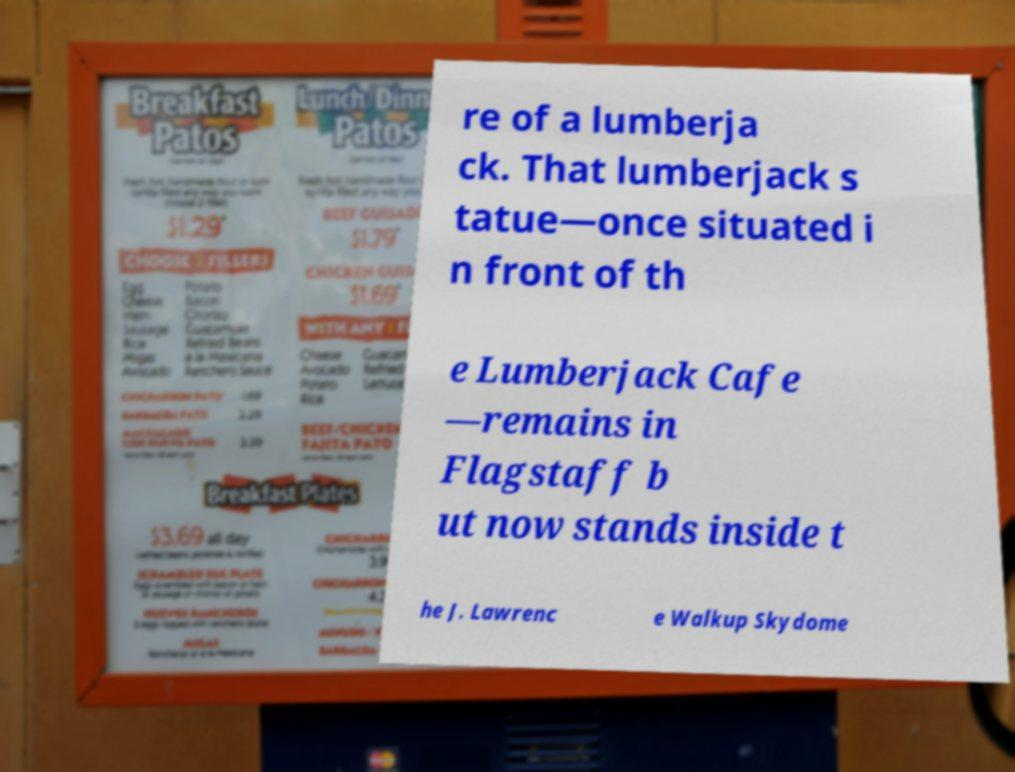Please read and relay the text visible in this image. What does it say? re of a lumberja ck. That lumberjack s tatue—once situated i n front of th e Lumberjack Cafe —remains in Flagstaff b ut now stands inside t he J. Lawrenc e Walkup Skydome 